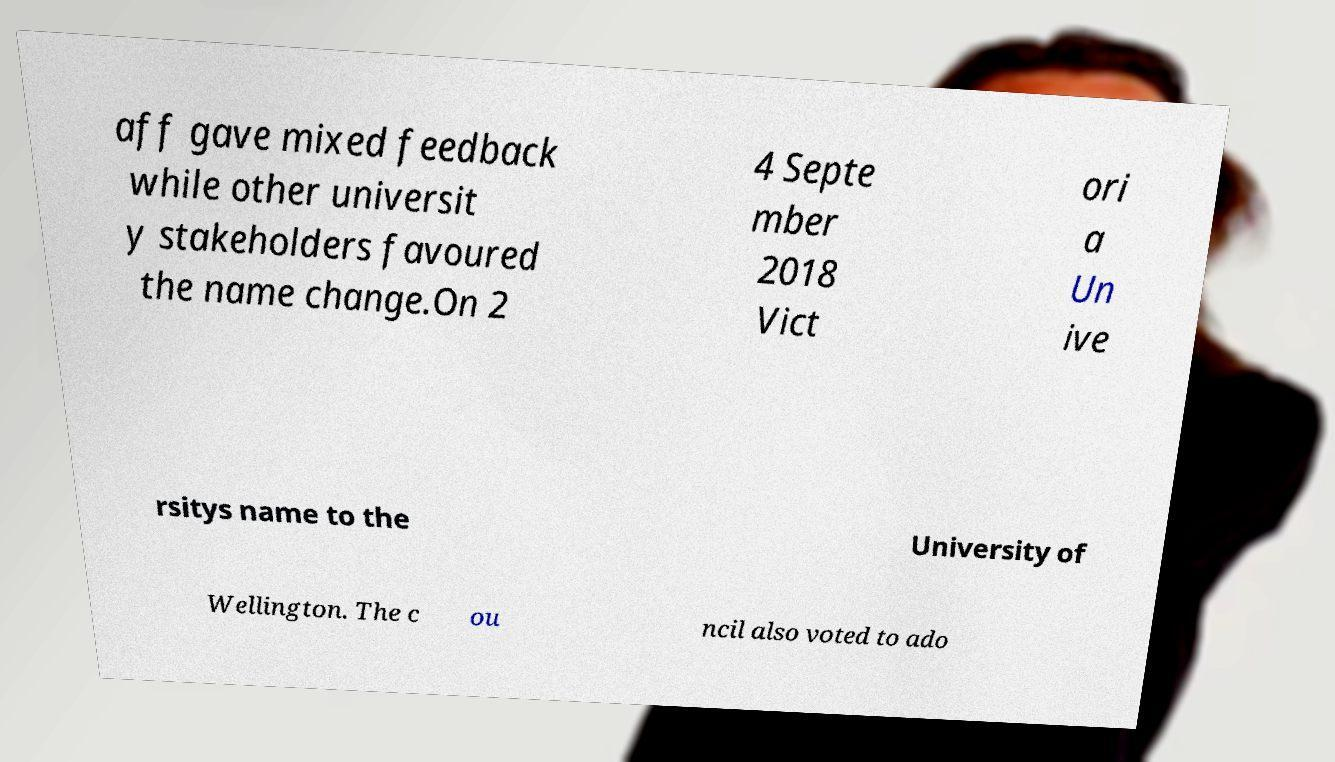For documentation purposes, I need the text within this image transcribed. Could you provide that? aff gave mixed feedback while other universit y stakeholders favoured the name change.On 2 4 Septe mber 2018 Vict ori a Un ive rsitys name to the University of Wellington. The c ou ncil also voted to ado 